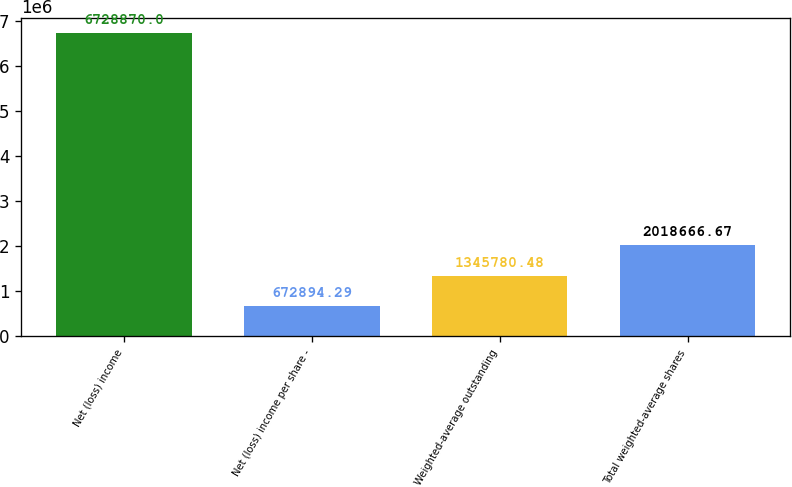<chart> <loc_0><loc_0><loc_500><loc_500><bar_chart><fcel>Net (loss) income<fcel>Net (loss) income per share -<fcel>Weighted-average outstanding<fcel>Total weighted-average shares<nl><fcel>6.72887e+06<fcel>672894<fcel>1.34578e+06<fcel>2.01867e+06<nl></chart> 